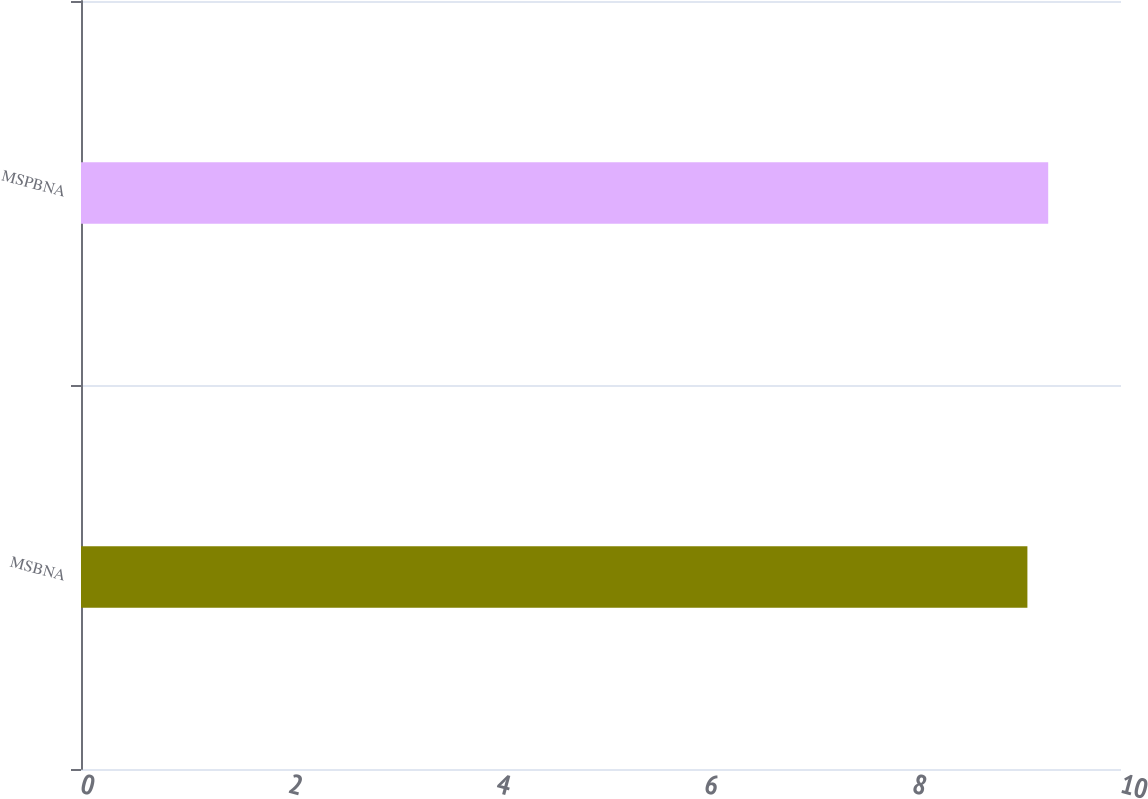Convert chart. <chart><loc_0><loc_0><loc_500><loc_500><bar_chart><fcel>MSBNA<fcel>MSPBNA<nl><fcel>9.1<fcel>9.3<nl></chart> 